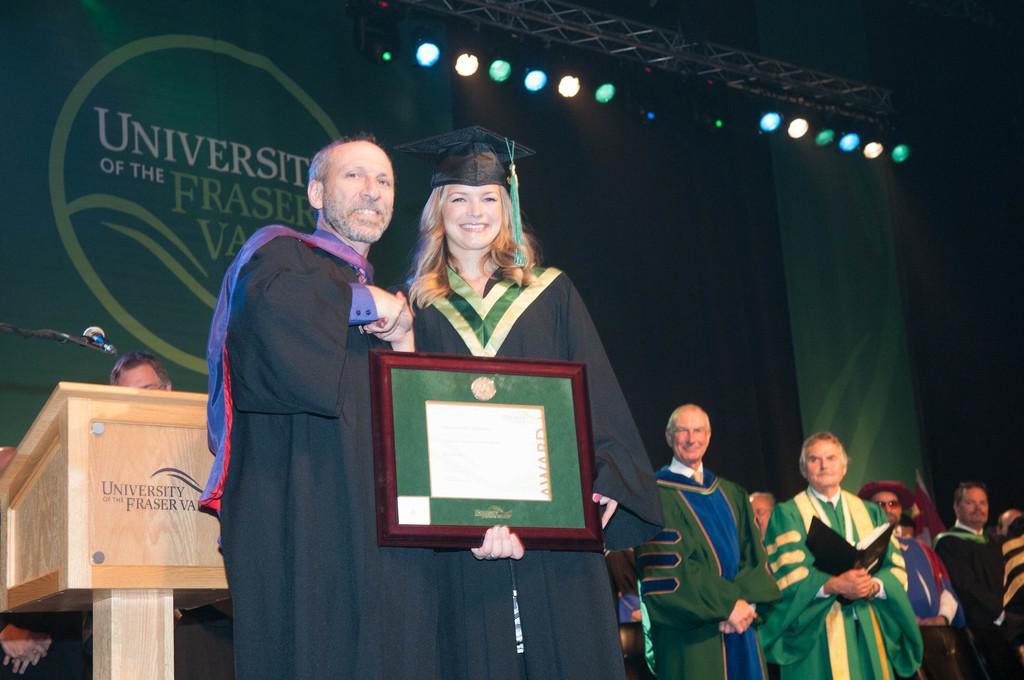How would you summarize this image in a sentence or two? In this image in the foreground there is one man and one woman who are holding photo frame, and in the background there are some people and one person is holding a book and left side of the image there is a podium and one mike and one person. In the background there are some boards, on the boards there is text and at the top there are some lights and some tower. 